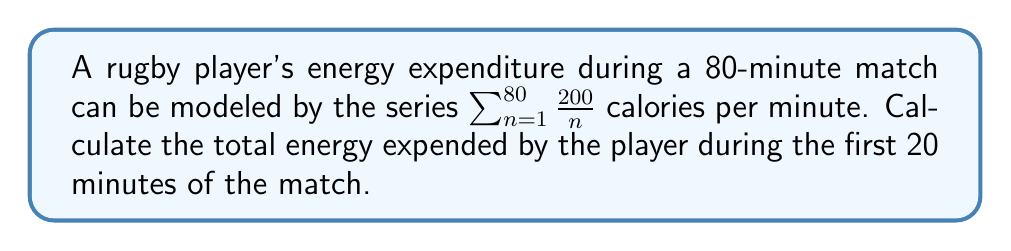Help me with this question. To solve this problem, we need to evaluate the partial sum of the series for the first 20 terms. Let's break it down step-by-step:

1) The series is given by $\sum_{n=1}^{80} \frac{200}{n}$, but we only need the first 20 terms.

2) We need to calculate $S_{20} = \sum_{n=1}^{20} \frac{200}{n}$

3) Let's expand this sum:

   $S_{20} = 200(1 + \frac{1}{2} + \frac{1}{3} + \frac{1}{4} + ... + \frac{1}{20})$

4) The expression in parentheses is a partial sum of the harmonic series. There's no simple closed form for this, but we can use the approximation for the nth harmonic number:

   $H_n \approx \ln(n) + \gamma$

   Where $\gamma$ is the Euler-Mascheroni constant, approximately 0.5772156649.

5) Using this approximation:

   $S_{20} \approx 200(\ln(20) + 0.5772156649)$

6) Calculating:
   $\ln(20) \approx 2.9957322736$
   $2.9957322736 + 0.5772156649 \approx 3.5729479385$

7) Therefore:
   $S_{20} \approx 200 * 3.5729479385 = 714.5895877$ calories

8) Rounding to a reasonable number of significant figures for physiological measurements:

   $S_{20} \approx 715$ calories

This represents the approximate total energy expended by the player during the first 20 minutes of the match.
Answer: 715 calories 